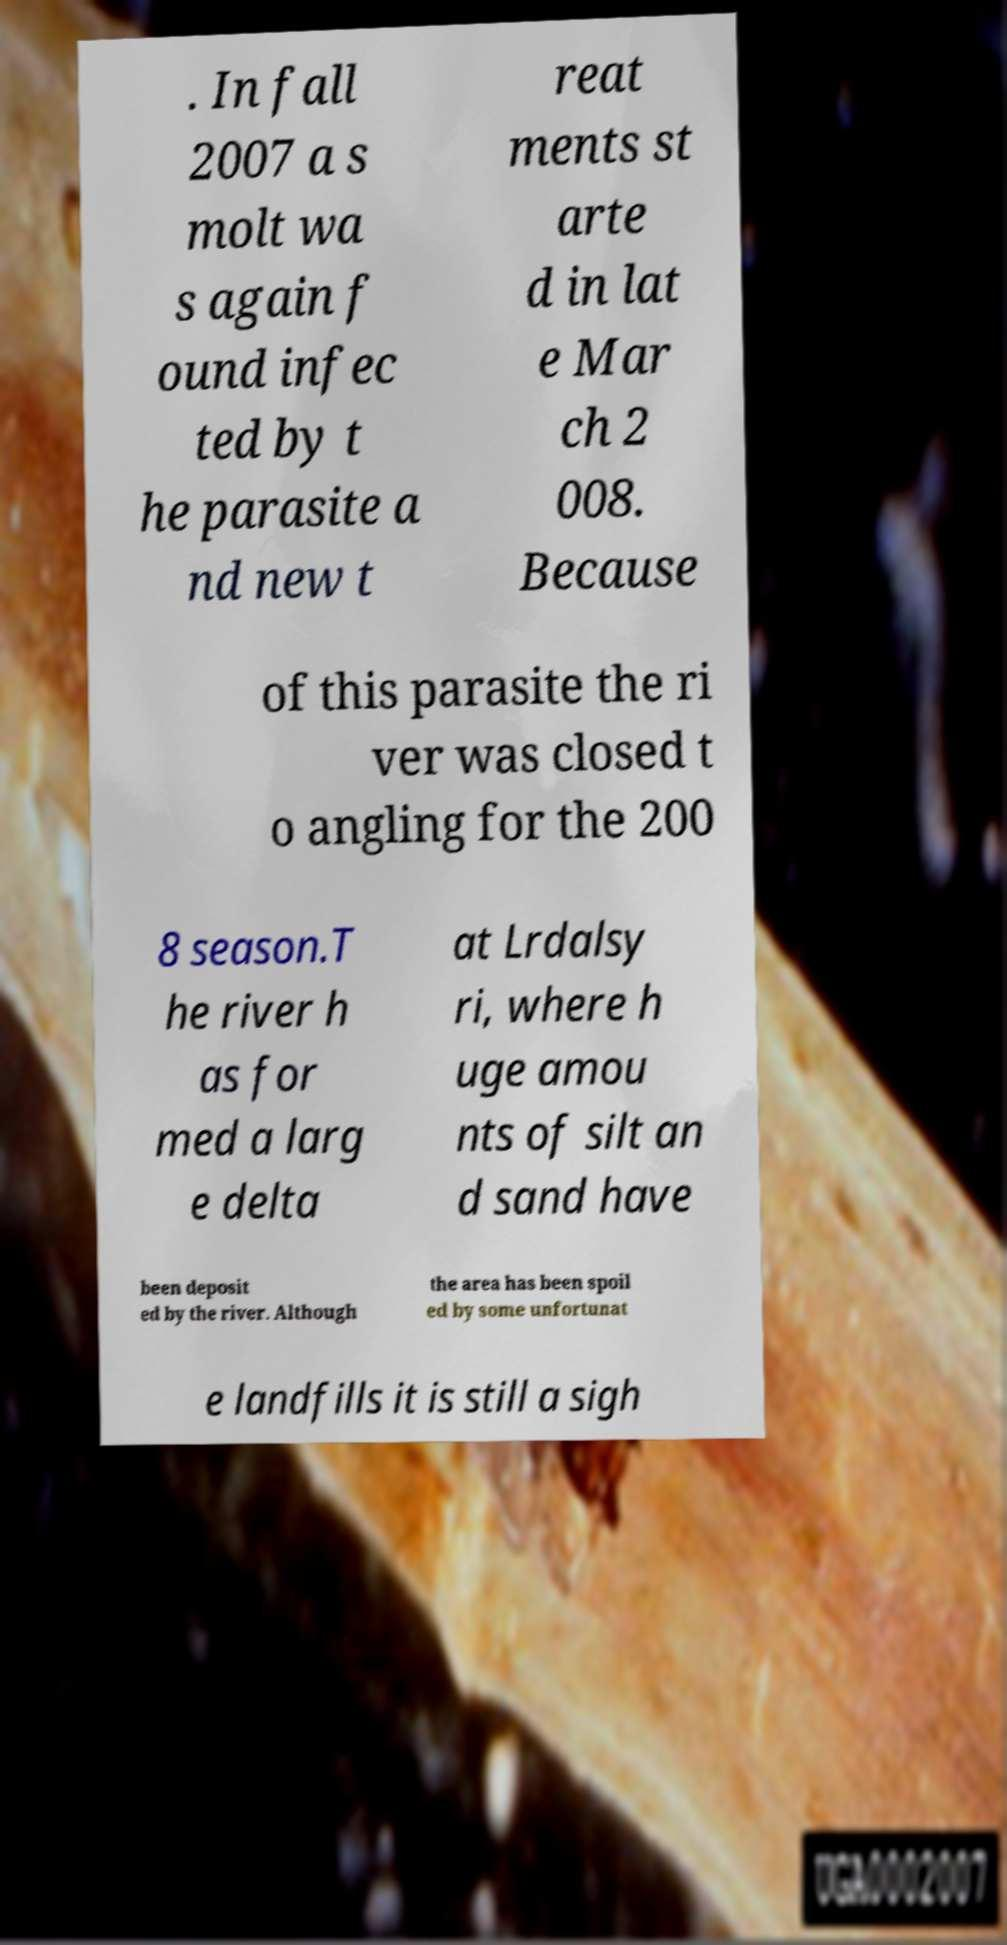Could you assist in decoding the text presented in this image and type it out clearly? . In fall 2007 a s molt wa s again f ound infec ted by t he parasite a nd new t reat ments st arte d in lat e Mar ch 2 008. Because of this parasite the ri ver was closed t o angling for the 200 8 season.T he river h as for med a larg e delta at Lrdalsy ri, where h uge amou nts of silt an d sand have been deposit ed by the river. Although the area has been spoil ed by some unfortunat e landfills it is still a sigh 